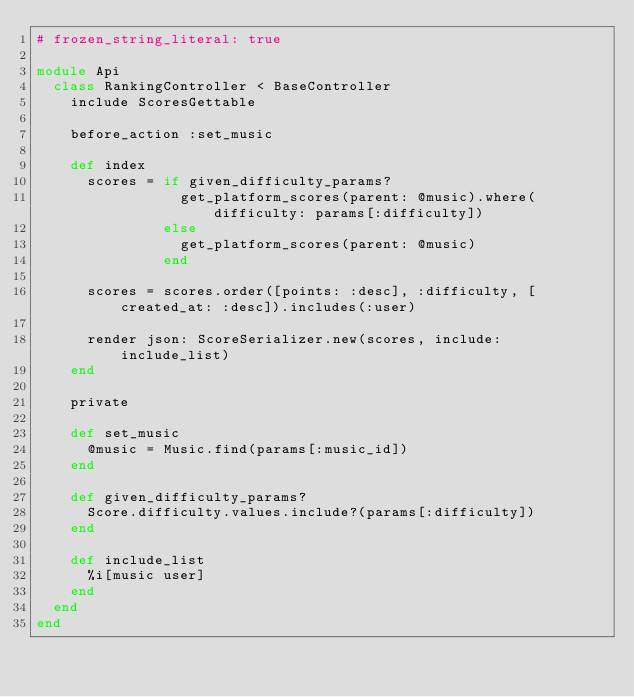<code> <loc_0><loc_0><loc_500><loc_500><_Ruby_># frozen_string_literal: true

module Api
  class RankingController < BaseController
    include ScoresGettable

    before_action :set_music

    def index
      scores = if given_difficulty_params?
                 get_platform_scores(parent: @music).where(difficulty: params[:difficulty])
               else
                 get_platform_scores(parent: @music)
               end

      scores = scores.order([points: :desc], :difficulty, [created_at: :desc]).includes(:user)

      render json: ScoreSerializer.new(scores, include: include_list)
    end

    private

    def set_music
      @music = Music.find(params[:music_id])
    end

    def given_difficulty_params?
      Score.difficulty.values.include?(params[:difficulty])
    end

    def include_list
      %i[music user]
    end
  end
end
</code> 